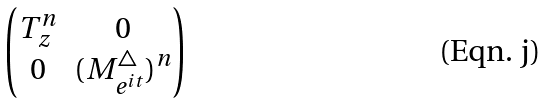<formula> <loc_0><loc_0><loc_500><loc_500>\begin{pmatrix} T _ { z } ^ { n } & 0 \\ 0 & ( M _ { e ^ { i t } } ^ { \bigtriangleup } ) ^ { n } \end{pmatrix}</formula> 